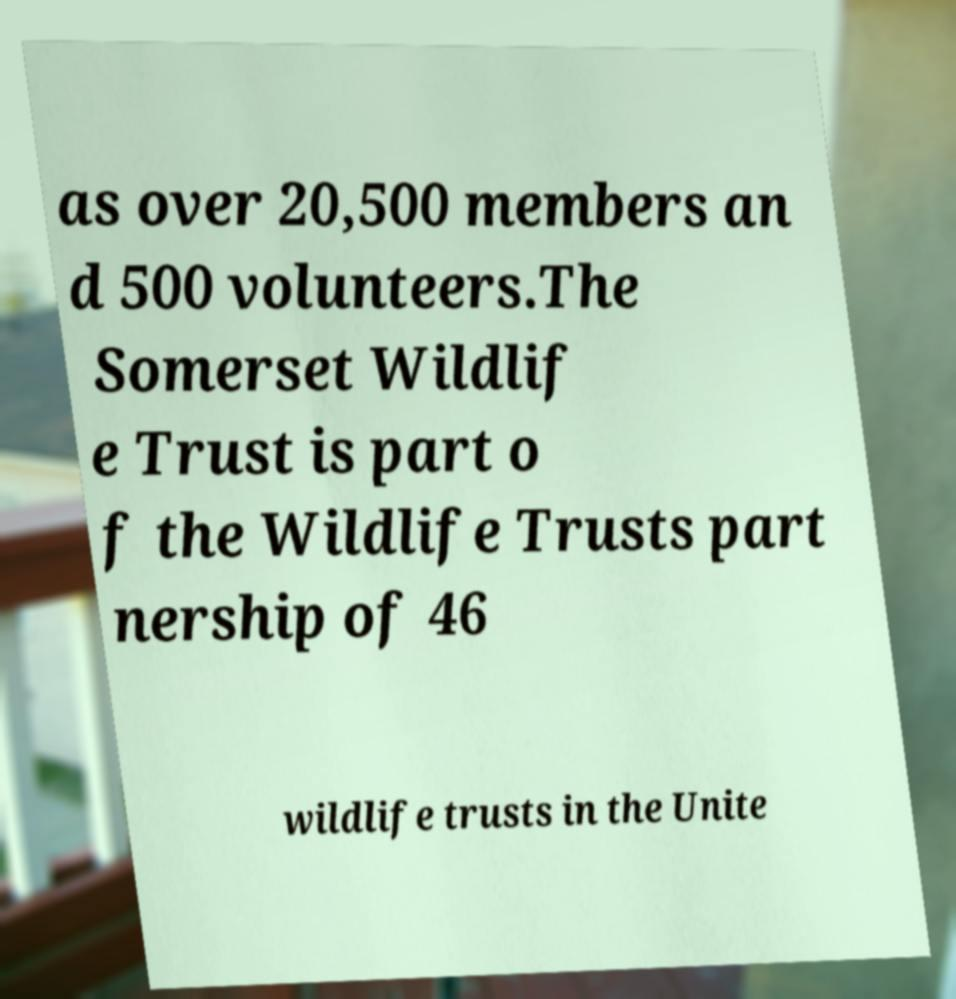Please identify and transcribe the text found in this image. as over 20,500 members an d 500 volunteers.The Somerset Wildlif e Trust is part o f the Wildlife Trusts part nership of 46 wildlife trusts in the Unite 